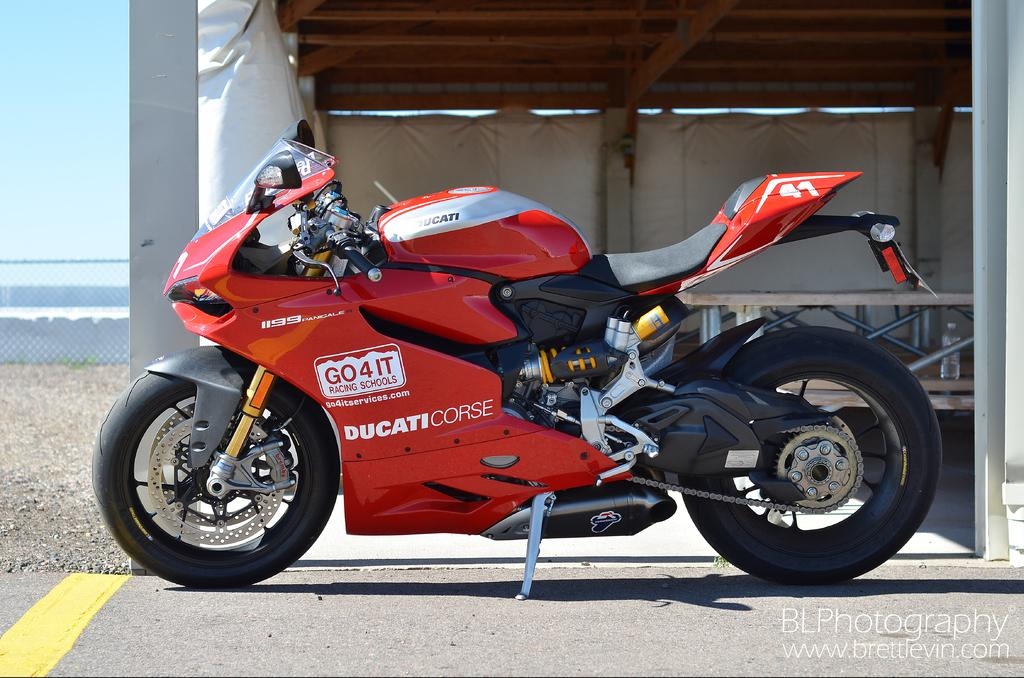Provide a one-sentence caption for the provided image. Ducaticorse red and black motorcycle parked on a highway. 